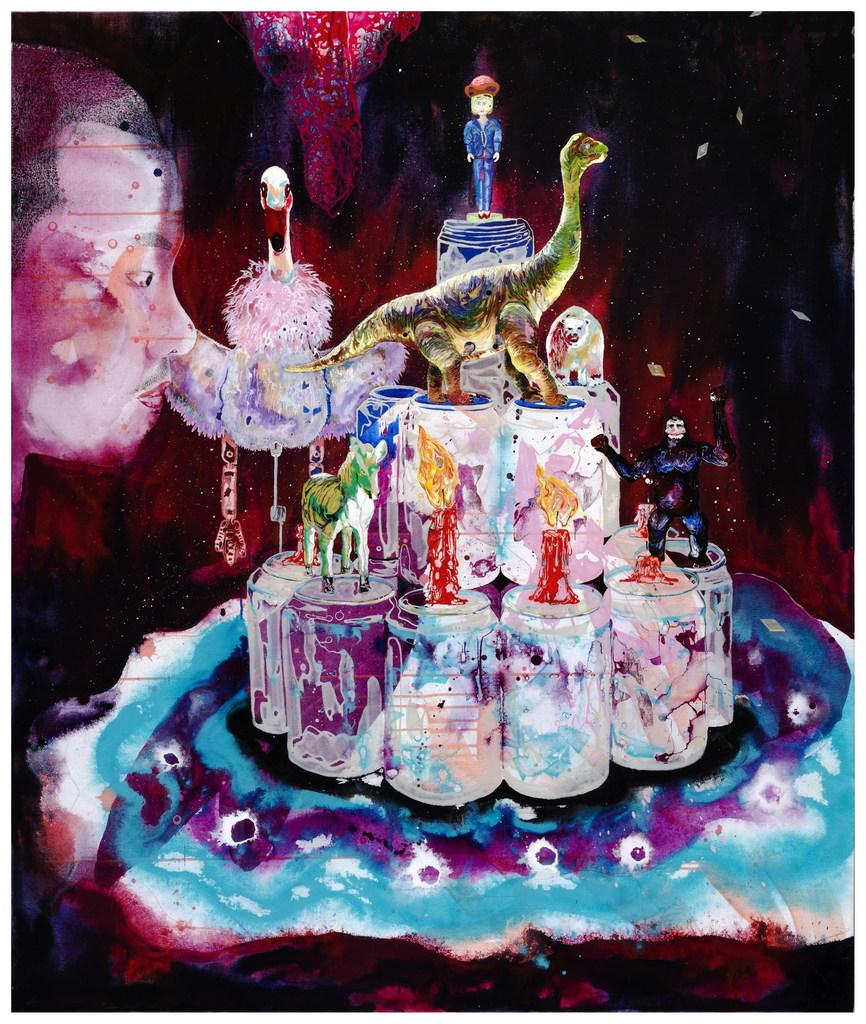What type of artwork is depicted in the image? The image is a painting. Who or what can be seen in the painting? There is a man and a toy in the shape of a boy in the painting. Can you tell me how many fairies are flying around the man in the painting? There are no fairies present in the painting; it only features a man and a toy in the shape of a boy. 